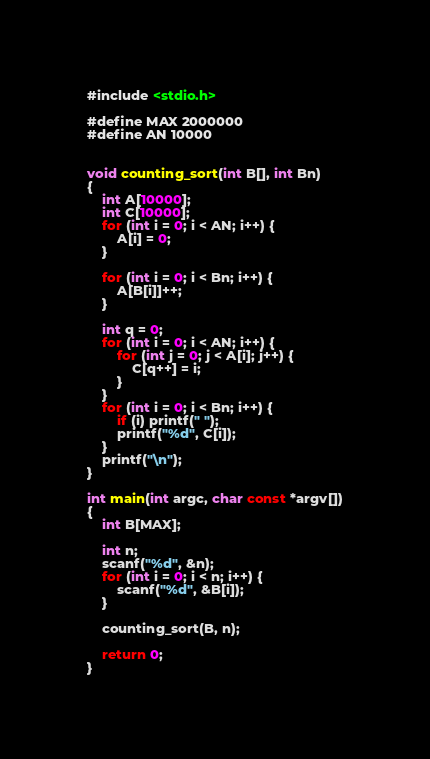<code> <loc_0><loc_0><loc_500><loc_500><_C_>#include <stdio.h>

#define MAX 2000000
#define AN 10000


void counting_sort(int B[], int Bn)
{
    int A[10000];
    int C[10000];
    for (int i = 0; i < AN; i++) {
        A[i] = 0;
    }

    for (int i = 0; i < Bn; i++) {
        A[B[i]]++;
    }

    int q = 0;
    for (int i = 0; i < AN; i++) {
        for (int j = 0; j < A[i]; j++) {
            C[q++] = i;
        }
    }
    for (int i = 0; i < Bn; i++) {
        if (i) printf(" ");
        printf("%d", C[i]);
    }
    printf("\n");
}

int main(int argc, char const *argv[])
{
    int B[MAX];

    int n;
    scanf("%d", &n);
    for (int i = 0; i < n; i++) {
        scanf("%d", &B[i]);
    }

    counting_sort(B, n);

    return 0;
}

</code> 